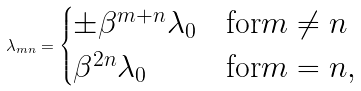Convert formula to latex. <formula><loc_0><loc_0><loc_500><loc_500>\lambda _ { m n } = \begin{cases} \pm \beta ^ { m + n } \lambda _ { 0 } & \text {for} m \neq n \\ \beta ^ { 2 n } \lambda _ { 0 } & \text {for} m = n , \end{cases}</formula> 